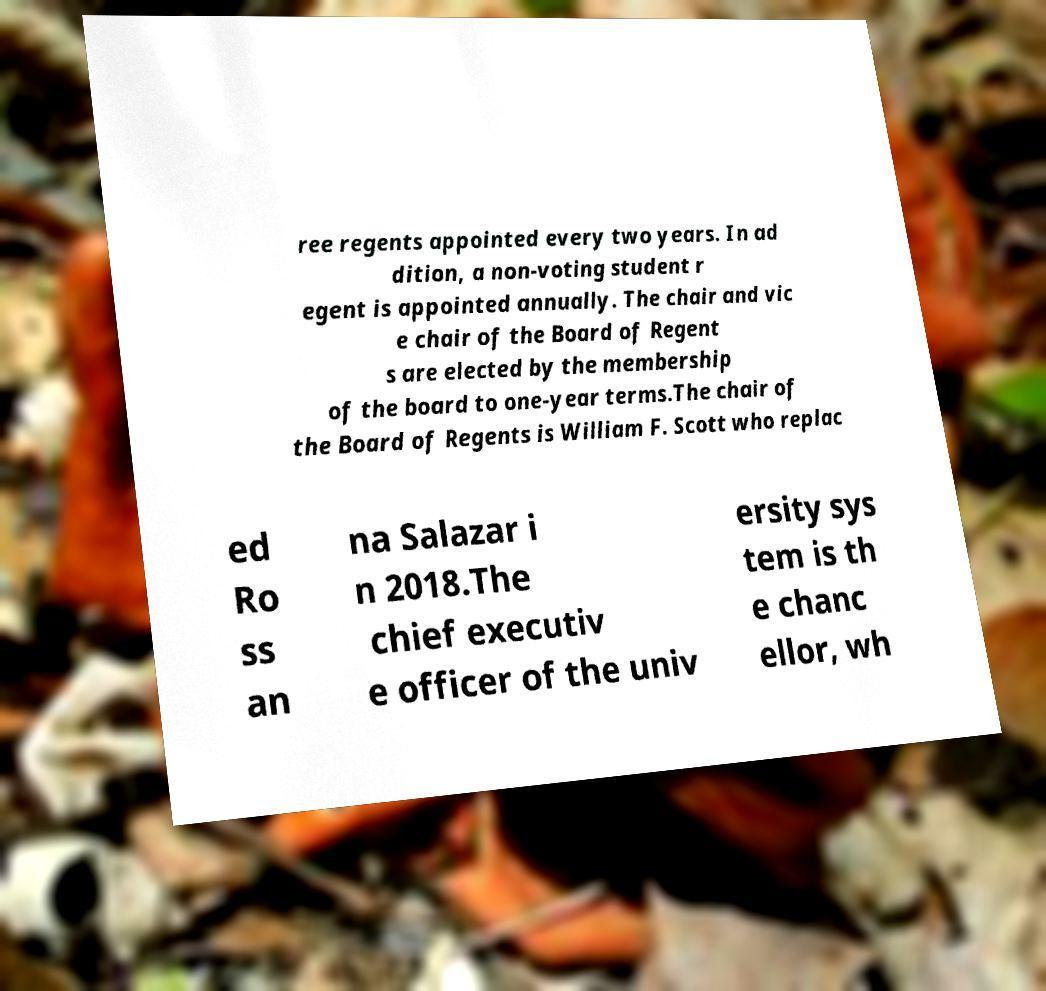I need the written content from this picture converted into text. Can you do that? ree regents appointed every two years. In ad dition, a non-voting student r egent is appointed annually. The chair and vic e chair of the Board of Regent s are elected by the membership of the board to one-year terms.The chair of the Board of Regents is William F. Scott who replac ed Ro ss an na Salazar i n 2018.The chief executiv e officer of the univ ersity sys tem is th e chanc ellor, wh 